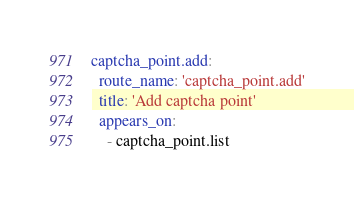<code> <loc_0><loc_0><loc_500><loc_500><_YAML_>captcha_point.add:
  route_name: 'captcha_point.add'
  title: 'Add captcha point'
  appears_on:
    - captcha_point.list
</code> 